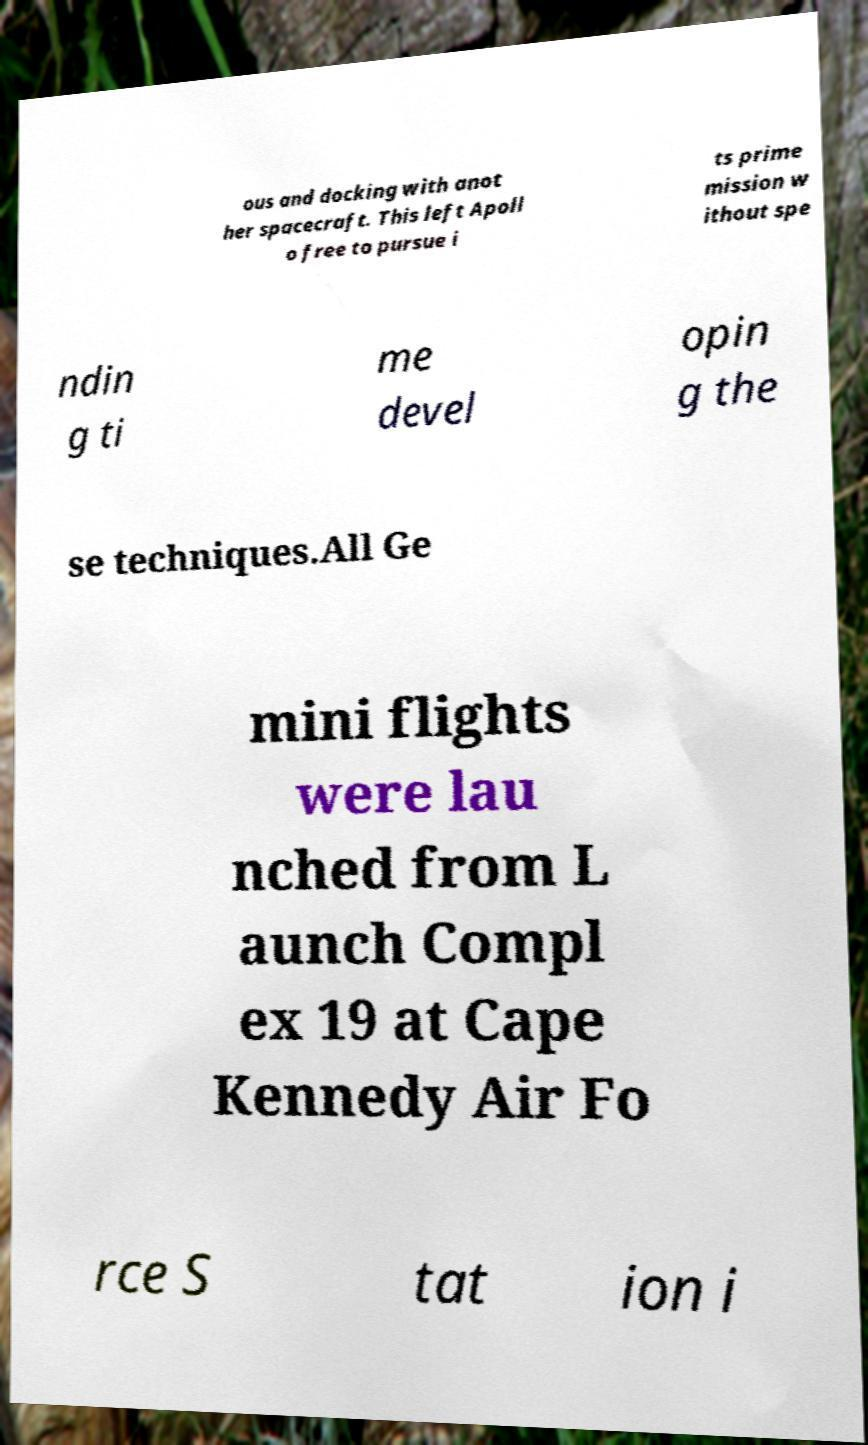For documentation purposes, I need the text within this image transcribed. Could you provide that? ous and docking with anot her spacecraft. This left Apoll o free to pursue i ts prime mission w ithout spe ndin g ti me devel opin g the se techniques.All Ge mini flights were lau nched from L aunch Compl ex 19 at Cape Kennedy Air Fo rce S tat ion i 